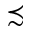Convert formula to latex. <formula><loc_0><loc_0><loc_500><loc_500>\prec s i m</formula> 